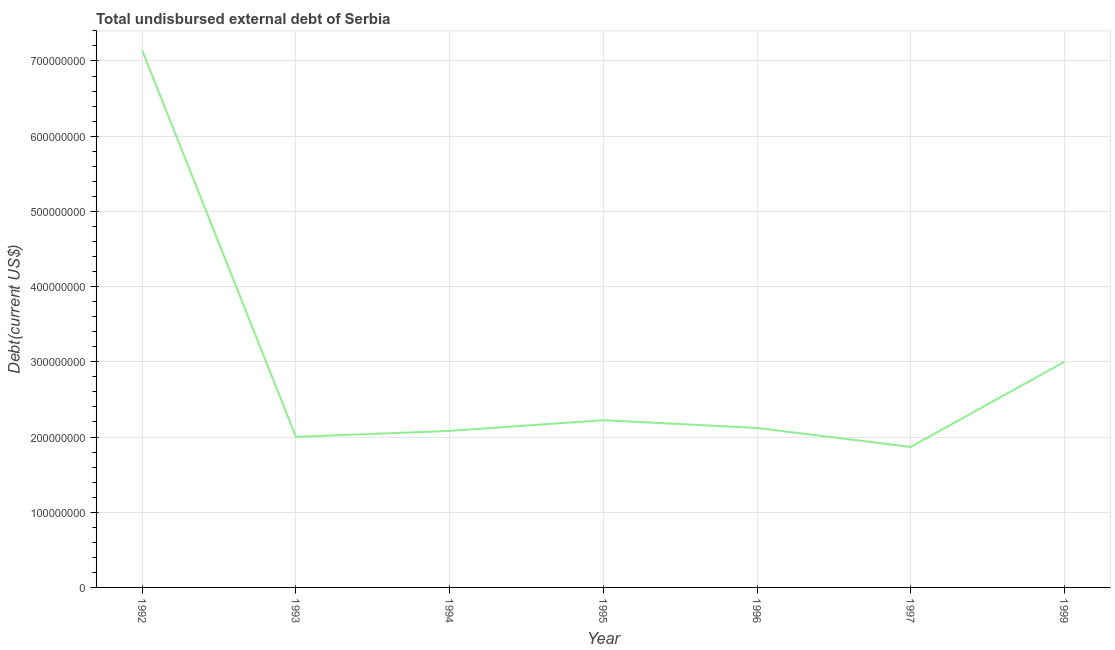What is the total debt in 1992?
Give a very brief answer. 7.14e+08. Across all years, what is the maximum total debt?
Make the answer very short. 7.14e+08. Across all years, what is the minimum total debt?
Give a very brief answer. 1.87e+08. In which year was the total debt maximum?
Keep it short and to the point. 1992. What is the sum of the total debt?
Provide a succinct answer. 2.04e+09. What is the difference between the total debt in 1996 and 1997?
Offer a very short reply. 2.52e+07. What is the average total debt per year?
Keep it short and to the point. 2.92e+08. What is the median total debt?
Keep it short and to the point. 2.12e+08. In how many years, is the total debt greater than 220000000 US$?
Provide a succinct answer. 3. Do a majority of the years between 1994 and 1997 (inclusive) have total debt greater than 540000000 US$?
Your response must be concise. No. What is the ratio of the total debt in 1995 to that in 1997?
Your response must be concise. 1.19. Is the total debt in 1992 less than that in 1999?
Your answer should be compact. No. Is the difference between the total debt in 1995 and 1996 greater than the difference between any two years?
Your answer should be very brief. No. What is the difference between the highest and the second highest total debt?
Offer a very short reply. 4.14e+08. Is the sum of the total debt in 1994 and 1999 greater than the maximum total debt across all years?
Provide a short and direct response. No. What is the difference between the highest and the lowest total debt?
Your answer should be very brief. 5.27e+08. Does the total debt monotonically increase over the years?
Your answer should be very brief. No. How many lines are there?
Ensure brevity in your answer.  1. How many years are there in the graph?
Your answer should be very brief. 7. Are the values on the major ticks of Y-axis written in scientific E-notation?
Your response must be concise. No. What is the title of the graph?
Your answer should be compact. Total undisbursed external debt of Serbia. What is the label or title of the X-axis?
Provide a short and direct response. Year. What is the label or title of the Y-axis?
Offer a terse response. Debt(current US$). What is the Debt(current US$) of 1992?
Keep it short and to the point. 7.14e+08. What is the Debt(current US$) of 1993?
Your response must be concise. 2.00e+08. What is the Debt(current US$) in 1994?
Make the answer very short. 2.08e+08. What is the Debt(current US$) in 1995?
Your answer should be compact. 2.22e+08. What is the Debt(current US$) in 1996?
Offer a very short reply. 2.12e+08. What is the Debt(current US$) of 1997?
Provide a short and direct response. 1.87e+08. What is the Debt(current US$) of 1999?
Offer a very short reply. 3.00e+08. What is the difference between the Debt(current US$) in 1992 and 1993?
Offer a terse response. 5.14e+08. What is the difference between the Debt(current US$) in 1992 and 1994?
Your answer should be very brief. 5.06e+08. What is the difference between the Debt(current US$) in 1992 and 1995?
Offer a very short reply. 4.91e+08. What is the difference between the Debt(current US$) in 1992 and 1996?
Provide a short and direct response. 5.02e+08. What is the difference between the Debt(current US$) in 1992 and 1997?
Provide a succinct answer. 5.27e+08. What is the difference between the Debt(current US$) in 1992 and 1999?
Provide a succinct answer. 4.14e+08. What is the difference between the Debt(current US$) in 1993 and 1994?
Offer a very short reply. -7.94e+06. What is the difference between the Debt(current US$) in 1993 and 1995?
Offer a terse response. -2.22e+07. What is the difference between the Debt(current US$) in 1993 and 1996?
Your answer should be very brief. -1.18e+07. What is the difference between the Debt(current US$) in 1993 and 1997?
Ensure brevity in your answer.  1.34e+07. What is the difference between the Debt(current US$) in 1993 and 1999?
Keep it short and to the point. -9.98e+07. What is the difference between the Debt(current US$) in 1994 and 1995?
Give a very brief answer. -1.42e+07. What is the difference between the Debt(current US$) in 1994 and 1996?
Offer a terse response. -3.88e+06. What is the difference between the Debt(current US$) in 1994 and 1997?
Provide a short and direct response. 2.13e+07. What is the difference between the Debt(current US$) in 1994 and 1999?
Give a very brief answer. -9.19e+07. What is the difference between the Debt(current US$) in 1995 and 1996?
Make the answer very short. 1.04e+07. What is the difference between the Debt(current US$) in 1995 and 1997?
Your response must be concise. 3.55e+07. What is the difference between the Debt(current US$) in 1995 and 1999?
Keep it short and to the point. -7.76e+07. What is the difference between the Debt(current US$) in 1996 and 1997?
Your answer should be compact. 2.52e+07. What is the difference between the Debt(current US$) in 1996 and 1999?
Make the answer very short. -8.80e+07. What is the difference between the Debt(current US$) in 1997 and 1999?
Provide a succinct answer. -1.13e+08. What is the ratio of the Debt(current US$) in 1992 to that in 1993?
Provide a short and direct response. 3.56. What is the ratio of the Debt(current US$) in 1992 to that in 1994?
Your answer should be compact. 3.43. What is the ratio of the Debt(current US$) in 1992 to that in 1995?
Your answer should be very brief. 3.21. What is the ratio of the Debt(current US$) in 1992 to that in 1996?
Your response must be concise. 3.37. What is the ratio of the Debt(current US$) in 1992 to that in 1997?
Offer a terse response. 3.82. What is the ratio of the Debt(current US$) in 1992 to that in 1999?
Your answer should be very brief. 2.38. What is the ratio of the Debt(current US$) in 1993 to that in 1996?
Ensure brevity in your answer.  0.94. What is the ratio of the Debt(current US$) in 1993 to that in 1997?
Give a very brief answer. 1.07. What is the ratio of the Debt(current US$) in 1993 to that in 1999?
Give a very brief answer. 0.67. What is the ratio of the Debt(current US$) in 1994 to that in 1995?
Offer a terse response. 0.94. What is the ratio of the Debt(current US$) in 1994 to that in 1997?
Your answer should be very brief. 1.11. What is the ratio of the Debt(current US$) in 1994 to that in 1999?
Make the answer very short. 0.69. What is the ratio of the Debt(current US$) in 1995 to that in 1996?
Provide a short and direct response. 1.05. What is the ratio of the Debt(current US$) in 1995 to that in 1997?
Your answer should be very brief. 1.19. What is the ratio of the Debt(current US$) in 1995 to that in 1999?
Offer a terse response. 0.74. What is the ratio of the Debt(current US$) in 1996 to that in 1997?
Offer a very short reply. 1.14. What is the ratio of the Debt(current US$) in 1996 to that in 1999?
Keep it short and to the point. 0.71. What is the ratio of the Debt(current US$) in 1997 to that in 1999?
Provide a succinct answer. 0.62. 